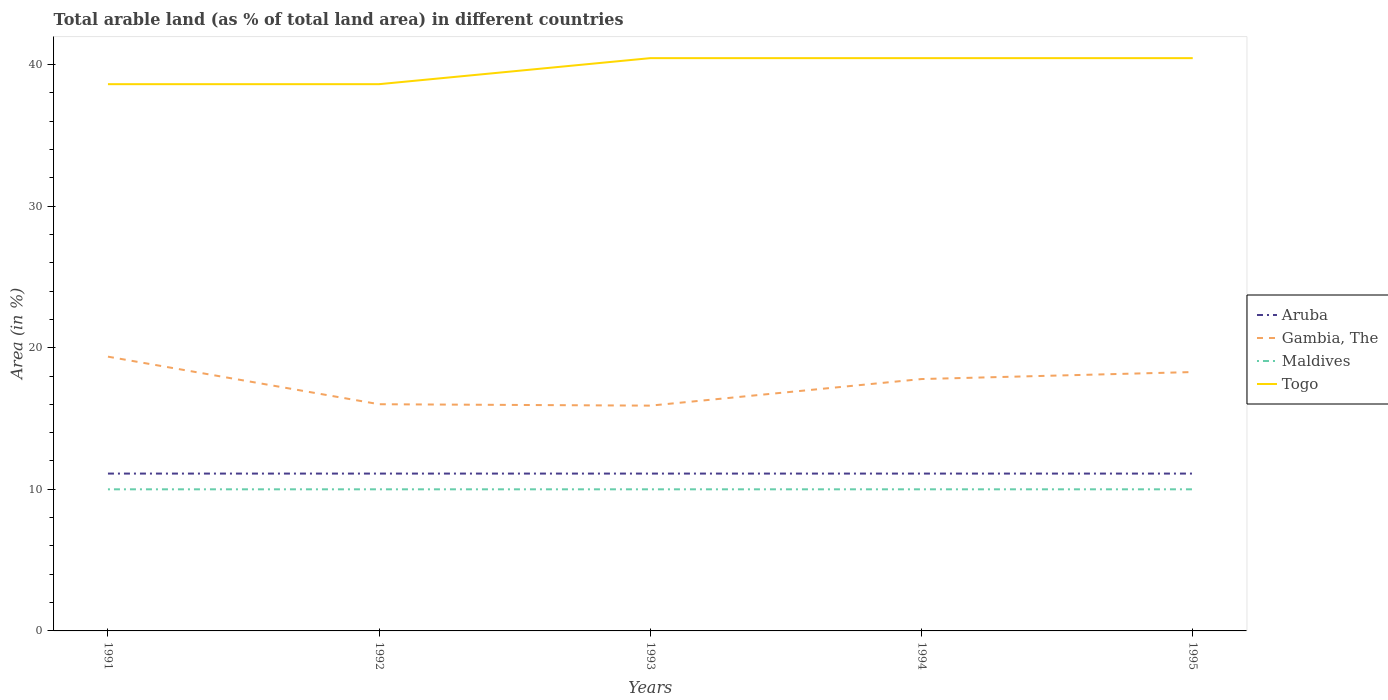How many different coloured lines are there?
Your response must be concise. 4. Across all years, what is the maximum percentage of arable land in Gambia, The?
Provide a succinct answer. 15.91. What is the total percentage of arable land in Gambia, The in the graph?
Give a very brief answer. 1.58. What is the difference between the highest and the second highest percentage of arable land in Togo?
Provide a short and direct response. 1.84. What is the difference between the highest and the lowest percentage of arable land in Gambia, The?
Your answer should be very brief. 3. How many lines are there?
Make the answer very short. 4. What is the difference between two consecutive major ticks on the Y-axis?
Your answer should be compact. 10. Are the values on the major ticks of Y-axis written in scientific E-notation?
Offer a very short reply. No. Does the graph contain any zero values?
Keep it short and to the point. No. How are the legend labels stacked?
Offer a very short reply. Vertical. What is the title of the graph?
Your response must be concise. Total arable land (as % of total land area) in different countries. What is the label or title of the Y-axis?
Your answer should be very brief. Area (in %). What is the Area (in %) in Aruba in 1991?
Provide a succinct answer. 11.11. What is the Area (in %) of Gambia, The in 1991?
Provide a succinct answer. 19.37. What is the Area (in %) in Maldives in 1991?
Ensure brevity in your answer.  10. What is the Area (in %) in Togo in 1991?
Make the answer very short. 38.61. What is the Area (in %) in Aruba in 1992?
Offer a terse response. 11.11. What is the Area (in %) in Gambia, The in 1992?
Your answer should be compact. 16.01. What is the Area (in %) of Togo in 1992?
Your answer should be compact. 38.61. What is the Area (in %) in Aruba in 1993?
Keep it short and to the point. 11.11. What is the Area (in %) of Gambia, The in 1993?
Your response must be concise. 15.91. What is the Area (in %) of Maldives in 1993?
Keep it short and to the point. 10. What is the Area (in %) of Togo in 1993?
Ensure brevity in your answer.  40.45. What is the Area (in %) of Aruba in 1994?
Make the answer very short. 11.11. What is the Area (in %) of Gambia, The in 1994?
Give a very brief answer. 17.79. What is the Area (in %) in Togo in 1994?
Your answer should be compact. 40.45. What is the Area (in %) in Aruba in 1995?
Keep it short and to the point. 11.11. What is the Area (in %) in Gambia, The in 1995?
Keep it short and to the point. 18.28. What is the Area (in %) of Maldives in 1995?
Offer a very short reply. 10. What is the Area (in %) in Togo in 1995?
Provide a succinct answer. 40.45. Across all years, what is the maximum Area (in %) of Aruba?
Make the answer very short. 11.11. Across all years, what is the maximum Area (in %) of Gambia, The?
Your answer should be compact. 19.37. Across all years, what is the maximum Area (in %) of Maldives?
Provide a short and direct response. 10. Across all years, what is the maximum Area (in %) of Togo?
Your answer should be very brief. 40.45. Across all years, what is the minimum Area (in %) of Aruba?
Provide a short and direct response. 11.11. Across all years, what is the minimum Area (in %) of Gambia, The?
Keep it short and to the point. 15.91. Across all years, what is the minimum Area (in %) in Togo?
Keep it short and to the point. 38.61. What is the total Area (in %) in Aruba in the graph?
Offer a terse response. 55.56. What is the total Area (in %) in Gambia, The in the graph?
Offer a very short reply. 87.35. What is the total Area (in %) in Togo in the graph?
Provide a succinct answer. 198.57. What is the difference between the Area (in %) in Aruba in 1991 and that in 1992?
Your answer should be very brief. 0. What is the difference between the Area (in %) in Gambia, The in 1991 and that in 1992?
Your answer should be compact. 3.36. What is the difference between the Area (in %) of Togo in 1991 and that in 1992?
Offer a very short reply. 0. What is the difference between the Area (in %) of Aruba in 1991 and that in 1993?
Ensure brevity in your answer.  0. What is the difference between the Area (in %) of Gambia, The in 1991 and that in 1993?
Offer a terse response. 3.46. What is the difference between the Area (in %) in Maldives in 1991 and that in 1993?
Your answer should be compact. 0. What is the difference between the Area (in %) of Togo in 1991 and that in 1993?
Your answer should be compact. -1.84. What is the difference between the Area (in %) in Gambia, The in 1991 and that in 1994?
Provide a succinct answer. 1.58. What is the difference between the Area (in %) of Maldives in 1991 and that in 1994?
Your answer should be compact. 0. What is the difference between the Area (in %) of Togo in 1991 and that in 1994?
Your response must be concise. -1.84. What is the difference between the Area (in %) of Aruba in 1991 and that in 1995?
Your answer should be compact. 0. What is the difference between the Area (in %) of Gambia, The in 1991 and that in 1995?
Give a very brief answer. 1.09. What is the difference between the Area (in %) in Togo in 1991 and that in 1995?
Give a very brief answer. -1.84. What is the difference between the Area (in %) in Aruba in 1992 and that in 1993?
Offer a terse response. 0. What is the difference between the Area (in %) in Gambia, The in 1992 and that in 1993?
Keep it short and to the point. 0.1. What is the difference between the Area (in %) in Togo in 1992 and that in 1993?
Your answer should be compact. -1.84. What is the difference between the Area (in %) of Gambia, The in 1992 and that in 1994?
Make the answer very short. -1.78. What is the difference between the Area (in %) in Maldives in 1992 and that in 1994?
Your answer should be very brief. 0. What is the difference between the Area (in %) in Togo in 1992 and that in 1994?
Provide a short and direct response. -1.84. What is the difference between the Area (in %) of Aruba in 1992 and that in 1995?
Give a very brief answer. 0. What is the difference between the Area (in %) of Gambia, The in 1992 and that in 1995?
Offer a terse response. -2.27. What is the difference between the Area (in %) in Maldives in 1992 and that in 1995?
Provide a succinct answer. 0. What is the difference between the Area (in %) of Togo in 1992 and that in 1995?
Provide a succinct answer. -1.84. What is the difference between the Area (in %) of Aruba in 1993 and that in 1994?
Provide a succinct answer. 0. What is the difference between the Area (in %) in Gambia, The in 1993 and that in 1994?
Offer a very short reply. -1.88. What is the difference between the Area (in %) in Gambia, The in 1993 and that in 1995?
Offer a very short reply. -2.37. What is the difference between the Area (in %) in Maldives in 1993 and that in 1995?
Give a very brief answer. 0. What is the difference between the Area (in %) of Aruba in 1994 and that in 1995?
Your response must be concise. 0. What is the difference between the Area (in %) of Gambia, The in 1994 and that in 1995?
Keep it short and to the point. -0.49. What is the difference between the Area (in %) in Togo in 1994 and that in 1995?
Ensure brevity in your answer.  0. What is the difference between the Area (in %) in Aruba in 1991 and the Area (in %) in Gambia, The in 1992?
Provide a short and direct response. -4.9. What is the difference between the Area (in %) in Aruba in 1991 and the Area (in %) in Maldives in 1992?
Your answer should be very brief. 1.11. What is the difference between the Area (in %) of Aruba in 1991 and the Area (in %) of Togo in 1992?
Make the answer very short. -27.5. What is the difference between the Area (in %) in Gambia, The in 1991 and the Area (in %) in Maldives in 1992?
Give a very brief answer. 9.37. What is the difference between the Area (in %) of Gambia, The in 1991 and the Area (in %) of Togo in 1992?
Provide a short and direct response. -19.24. What is the difference between the Area (in %) in Maldives in 1991 and the Area (in %) in Togo in 1992?
Your answer should be compact. -28.61. What is the difference between the Area (in %) in Aruba in 1991 and the Area (in %) in Gambia, The in 1993?
Provide a short and direct response. -4.8. What is the difference between the Area (in %) in Aruba in 1991 and the Area (in %) in Togo in 1993?
Provide a succinct answer. -29.34. What is the difference between the Area (in %) in Gambia, The in 1991 and the Area (in %) in Maldives in 1993?
Make the answer very short. 9.37. What is the difference between the Area (in %) in Gambia, The in 1991 and the Area (in %) in Togo in 1993?
Provide a short and direct response. -21.08. What is the difference between the Area (in %) of Maldives in 1991 and the Area (in %) of Togo in 1993?
Ensure brevity in your answer.  -30.45. What is the difference between the Area (in %) of Aruba in 1991 and the Area (in %) of Gambia, The in 1994?
Offer a very short reply. -6.68. What is the difference between the Area (in %) in Aruba in 1991 and the Area (in %) in Togo in 1994?
Keep it short and to the point. -29.34. What is the difference between the Area (in %) in Gambia, The in 1991 and the Area (in %) in Maldives in 1994?
Keep it short and to the point. 9.37. What is the difference between the Area (in %) in Gambia, The in 1991 and the Area (in %) in Togo in 1994?
Provide a succinct answer. -21.08. What is the difference between the Area (in %) in Maldives in 1991 and the Area (in %) in Togo in 1994?
Offer a very short reply. -30.45. What is the difference between the Area (in %) in Aruba in 1991 and the Area (in %) in Gambia, The in 1995?
Keep it short and to the point. -7.17. What is the difference between the Area (in %) of Aruba in 1991 and the Area (in %) of Maldives in 1995?
Your answer should be very brief. 1.11. What is the difference between the Area (in %) of Aruba in 1991 and the Area (in %) of Togo in 1995?
Give a very brief answer. -29.34. What is the difference between the Area (in %) of Gambia, The in 1991 and the Area (in %) of Maldives in 1995?
Your answer should be very brief. 9.37. What is the difference between the Area (in %) of Gambia, The in 1991 and the Area (in %) of Togo in 1995?
Ensure brevity in your answer.  -21.08. What is the difference between the Area (in %) in Maldives in 1991 and the Area (in %) in Togo in 1995?
Provide a short and direct response. -30.45. What is the difference between the Area (in %) in Aruba in 1992 and the Area (in %) in Gambia, The in 1993?
Provide a succinct answer. -4.8. What is the difference between the Area (in %) in Aruba in 1992 and the Area (in %) in Maldives in 1993?
Give a very brief answer. 1.11. What is the difference between the Area (in %) in Aruba in 1992 and the Area (in %) in Togo in 1993?
Provide a succinct answer. -29.34. What is the difference between the Area (in %) of Gambia, The in 1992 and the Area (in %) of Maldives in 1993?
Provide a short and direct response. 6.01. What is the difference between the Area (in %) in Gambia, The in 1992 and the Area (in %) in Togo in 1993?
Your response must be concise. -24.44. What is the difference between the Area (in %) of Maldives in 1992 and the Area (in %) of Togo in 1993?
Your answer should be very brief. -30.45. What is the difference between the Area (in %) in Aruba in 1992 and the Area (in %) in Gambia, The in 1994?
Provide a short and direct response. -6.68. What is the difference between the Area (in %) of Aruba in 1992 and the Area (in %) of Maldives in 1994?
Your response must be concise. 1.11. What is the difference between the Area (in %) in Aruba in 1992 and the Area (in %) in Togo in 1994?
Give a very brief answer. -29.34. What is the difference between the Area (in %) in Gambia, The in 1992 and the Area (in %) in Maldives in 1994?
Ensure brevity in your answer.  6.01. What is the difference between the Area (in %) in Gambia, The in 1992 and the Area (in %) in Togo in 1994?
Ensure brevity in your answer.  -24.44. What is the difference between the Area (in %) in Maldives in 1992 and the Area (in %) in Togo in 1994?
Ensure brevity in your answer.  -30.45. What is the difference between the Area (in %) of Aruba in 1992 and the Area (in %) of Gambia, The in 1995?
Provide a succinct answer. -7.17. What is the difference between the Area (in %) in Aruba in 1992 and the Area (in %) in Togo in 1995?
Your answer should be very brief. -29.34. What is the difference between the Area (in %) in Gambia, The in 1992 and the Area (in %) in Maldives in 1995?
Offer a terse response. 6.01. What is the difference between the Area (in %) of Gambia, The in 1992 and the Area (in %) of Togo in 1995?
Provide a succinct answer. -24.44. What is the difference between the Area (in %) of Maldives in 1992 and the Area (in %) of Togo in 1995?
Ensure brevity in your answer.  -30.45. What is the difference between the Area (in %) in Aruba in 1993 and the Area (in %) in Gambia, The in 1994?
Give a very brief answer. -6.68. What is the difference between the Area (in %) of Aruba in 1993 and the Area (in %) of Maldives in 1994?
Offer a very short reply. 1.11. What is the difference between the Area (in %) in Aruba in 1993 and the Area (in %) in Togo in 1994?
Give a very brief answer. -29.34. What is the difference between the Area (in %) in Gambia, The in 1993 and the Area (in %) in Maldives in 1994?
Your response must be concise. 5.91. What is the difference between the Area (in %) in Gambia, The in 1993 and the Area (in %) in Togo in 1994?
Your response must be concise. -24.54. What is the difference between the Area (in %) of Maldives in 1993 and the Area (in %) of Togo in 1994?
Your answer should be very brief. -30.45. What is the difference between the Area (in %) in Aruba in 1993 and the Area (in %) in Gambia, The in 1995?
Provide a short and direct response. -7.17. What is the difference between the Area (in %) of Aruba in 1993 and the Area (in %) of Maldives in 1995?
Make the answer very short. 1.11. What is the difference between the Area (in %) in Aruba in 1993 and the Area (in %) in Togo in 1995?
Offer a very short reply. -29.34. What is the difference between the Area (in %) in Gambia, The in 1993 and the Area (in %) in Maldives in 1995?
Make the answer very short. 5.91. What is the difference between the Area (in %) in Gambia, The in 1993 and the Area (in %) in Togo in 1995?
Give a very brief answer. -24.54. What is the difference between the Area (in %) of Maldives in 1993 and the Area (in %) of Togo in 1995?
Give a very brief answer. -30.45. What is the difference between the Area (in %) of Aruba in 1994 and the Area (in %) of Gambia, The in 1995?
Ensure brevity in your answer.  -7.17. What is the difference between the Area (in %) in Aruba in 1994 and the Area (in %) in Togo in 1995?
Offer a terse response. -29.34. What is the difference between the Area (in %) in Gambia, The in 1994 and the Area (in %) in Maldives in 1995?
Your answer should be compact. 7.79. What is the difference between the Area (in %) in Gambia, The in 1994 and the Area (in %) in Togo in 1995?
Ensure brevity in your answer.  -22.66. What is the difference between the Area (in %) in Maldives in 1994 and the Area (in %) in Togo in 1995?
Provide a succinct answer. -30.45. What is the average Area (in %) of Aruba per year?
Keep it short and to the point. 11.11. What is the average Area (in %) in Gambia, The per year?
Ensure brevity in your answer.  17.47. What is the average Area (in %) in Togo per year?
Make the answer very short. 39.71. In the year 1991, what is the difference between the Area (in %) of Aruba and Area (in %) of Gambia, The?
Make the answer very short. -8.26. In the year 1991, what is the difference between the Area (in %) in Aruba and Area (in %) in Togo?
Your answer should be compact. -27.5. In the year 1991, what is the difference between the Area (in %) of Gambia, The and Area (in %) of Maldives?
Offer a terse response. 9.37. In the year 1991, what is the difference between the Area (in %) in Gambia, The and Area (in %) in Togo?
Provide a short and direct response. -19.24. In the year 1991, what is the difference between the Area (in %) in Maldives and Area (in %) in Togo?
Offer a terse response. -28.61. In the year 1992, what is the difference between the Area (in %) in Aruba and Area (in %) in Gambia, The?
Offer a very short reply. -4.9. In the year 1992, what is the difference between the Area (in %) in Aruba and Area (in %) in Togo?
Make the answer very short. -27.5. In the year 1992, what is the difference between the Area (in %) in Gambia, The and Area (in %) in Maldives?
Your answer should be compact. 6.01. In the year 1992, what is the difference between the Area (in %) in Gambia, The and Area (in %) in Togo?
Give a very brief answer. -22.6. In the year 1992, what is the difference between the Area (in %) of Maldives and Area (in %) of Togo?
Offer a terse response. -28.61. In the year 1993, what is the difference between the Area (in %) of Aruba and Area (in %) of Gambia, The?
Provide a succinct answer. -4.8. In the year 1993, what is the difference between the Area (in %) in Aruba and Area (in %) in Togo?
Give a very brief answer. -29.34. In the year 1993, what is the difference between the Area (in %) of Gambia, The and Area (in %) of Maldives?
Your response must be concise. 5.91. In the year 1993, what is the difference between the Area (in %) in Gambia, The and Area (in %) in Togo?
Your answer should be very brief. -24.54. In the year 1993, what is the difference between the Area (in %) in Maldives and Area (in %) in Togo?
Make the answer very short. -30.45. In the year 1994, what is the difference between the Area (in %) of Aruba and Area (in %) of Gambia, The?
Provide a succinct answer. -6.68. In the year 1994, what is the difference between the Area (in %) of Aruba and Area (in %) of Togo?
Keep it short and to the point. -29.34. In the year 1994, what is the difference between the Area (in %) of Gambia, The and Area (in %) of Maldives?
Give a very brief answer. 7.79. In the year 1994, what is the difference between the Area (in %) in Gambia, The and Area (in %) in Togo?
Make the answer very short. -22.66. In the year 1994, what is the difference between the Area (in %) in Maldives and Area (in %) in Togo?
Your answer should be compact. -30.45. In the year 1995, what is the difference between the Area (in %) in Aruba and Area (in %) in Gambia, The?
Offer a terse response. -7.17. In the year 1995, what is the difference between the Area (in %) in Aruba and Area (in %) in Maldives?
Provide a short and direct response. 1.11. In the year 1995, what is the difference between the Area (in %) of Aruba and Area (in %) of Togo?
Your answer should be very brief. -29.34. In the year 1995, what is the difference between the Area (in %) of Gambia, The and Area (in %) of Maldives?
Provide a short and direct response. 8.28. In the year 1995, what is the difference between the Area (in %) of Gambia, The and Area (in %) of Togo?
Give a very brief answer. -22.17. In the year 1995, what is the difference between the Area (in %) of Maldives and Area (in %) of Togo?
Offer a very short reply. -30.45. What is the ratio of the Area (in %) of Gambia, The in 1991 to that in 1992?
Keep it short and to the point. 1.21. What is the ratio of the Area (in %) in Gambia, The in 1991 to that in 1993?
Give a very brief answer. 1.22. What is the ratio of the Area (in %) in Togo in 1991 to that in 1993?
Your response must be concise. 0.95. What is the ratio of the Area (in %) of Aruba in 1991 to that in 1994?
Your answer should be compact. 1. What is the ratio of the Area (in %) of Gambia, The in 1991 to that in 1994?
Offer a terse response. 1.09. What is the ratio of the Area (in %) in Maldives in 1991 to that in 1994?
Offer a very short reply. 1. What is the ratio of the Area (in %) of Togo in 1991 to that in 1994?
Your answer should be very brief. 0.95. What is the ratio of the Area (in %) in Aruba in 1991 to that in 1995?
Make the answer very short. 1. What is the ratio of the Area (in %) of Gambia, The in 1991 to that in 1995?
Your answer should be very brief. 1.06. What is the ratio of the Area (in %) of Maldives in 1991 to that in 1995?
Provide a succinct answer. 1. What is the ratio of the Area (in %) in Togo in 1991 to that in 1995?
Ensure brevity in your answer.  0.95. What is the ratio of the Area (in %) of Aruba in 1992 to that in 1993?
Make the answer very short. 1. What is the ratio of the Area (in %) of Togo in 1992 to that in 1993?
Offer a very short reply. 0.95. What is the ratio of the Area (in %) in Togo in 1992 to that in 1994?
Give a very brief answer. 0.95. What is the ratio of the Area (in %) of Aruba in 1992 to that in 1995?
Provide a succinct answer. 1. What is the ratio of the Area (in %) in Gambia, The in 1992 to that in 1995?
Keep it short and to the point. 0.88. What is the ratio of the Area (in %) of Togo in 1992 to that in 1995?
Give a very brief answer. 0.95. What is the ratio of the Area (in %) in Aruba in 1993 to that in 1994?
Ensure brevity in your answer.  1. What is the ratio of the Area (in %) of Gambia, The in 1993 to that in 1994?
Give a very brief answer. 0.89. What is the ratio of the Area (in %) of Maldives in 1993 to that in 1994?
Make the answer very short. 1. What is the ratio of the Area (in %) in Aruba in 1993 to that in 1995?
Make the answer very short. 1. What is the ratio of the Area (in %) in Gambia, The in 1993 to that in 1995?
Provide a short and direct response. 0.87. What is the ratio of the Area (in %) of Maldives in 1993 to that in 1995?
Offer a very short reply. 1. What is the ratio of the Area (in %) in Aruba in 1994 to that in 1995?
Offer a terse response. 1. What is the ratio of the Area (in %) of Gambia, The in 1994 to that in 1995?
Offer a very short reply. 0.97. What is the difference between the highest and the second highest Area (in %) in Gambia, The?
Your response must be concise. 1.09. What is the difference between the highest and the second highest Area (in %) in Maldives?
Keep it short and to the point. 0. What is the difference between the highest and the second highest Area (in %) in Togo?
Provide a succinct answer. 0. What is the difference between the highest and the lowest Area (in %) in Gambia, The?
Offer a terse response. 3.46. What is the difference between the highest and the lowest Area (in %) in Maldives?
Make the answer very short. 0. What is the difference between the highest and the lowest Area (in %) of Togo?
Ensure brevity in your answer.  1.84. 